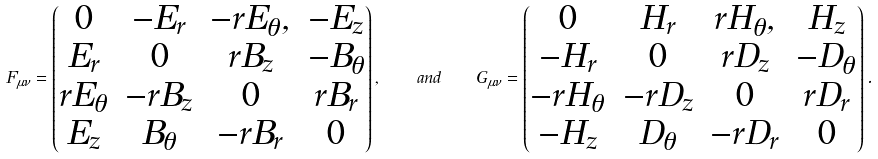Convert formula to latex. <formula><loc_0><loc_0><loc_500><loc_500>F _ { \mu \nu } = \left ( \begin{matrix} 0 & - E _ { r } & - r E _ { \theta } , & - E _ { z } \\ E _ { r } & 0 & r B _ { z } & - B _ { \theta } \\ r E _ { \theta } & - r B _ { z } & 0 & r B _ { r } \\ E _ { z } & B _ { \theta } & - r B _ { r } & 0 \end{matrix} \right ) , \quad a n d \quad G _ { \mu \nu } = \left ( \begin{matrix} 0 & H _ { r } & r H _ { \theta } , & H _ { z } \\ - H _ { r } & 0 & r D _ { z } & - D _ { \theta } \\ - r H _ { \theta } & - r D _ { z } & 0 & r D _ { r } \\ - H _ { z } & D _ { \theta } & - r D _ { r } & 0 \end{matrix} \right ) .</formula> 